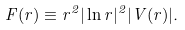Convert formula to latex. <formula><loc_0><loc_0><loc_500><loc_500>F ( r ) \equiv r ^ { 2 } | \ln r | ^ { 2 } | V ( r ) | .</formula> 